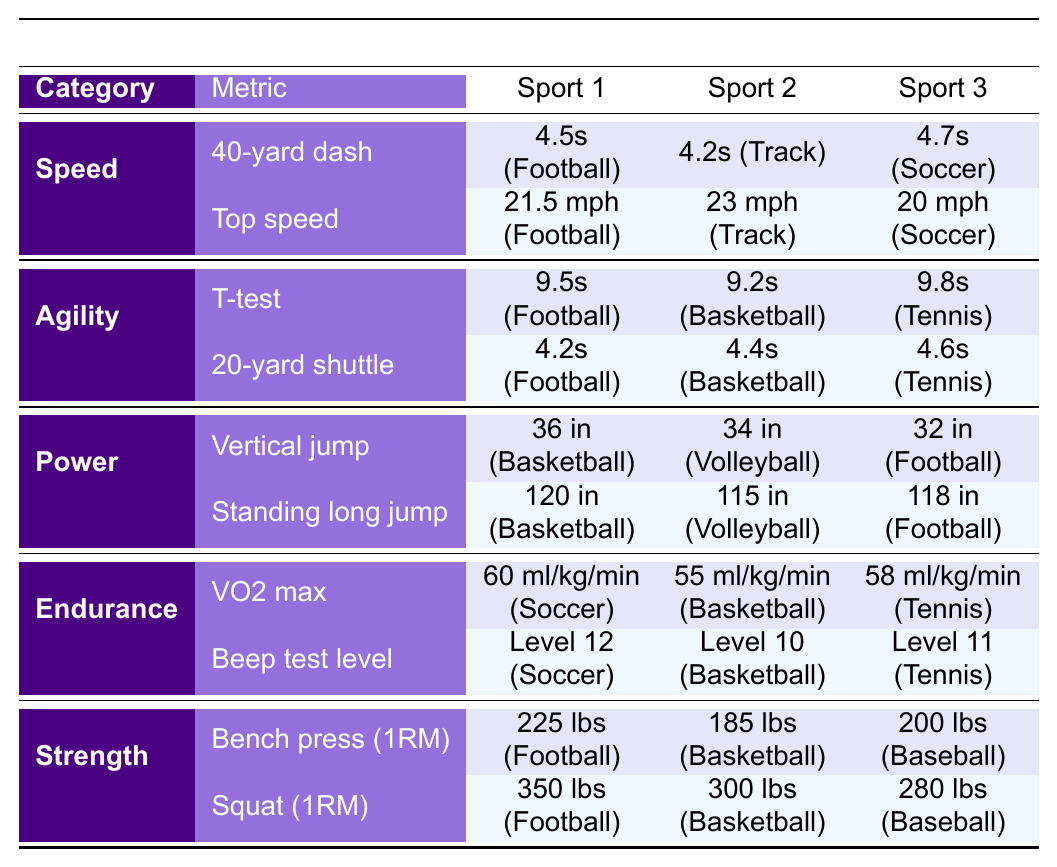What's the fastest time for the 40-yard dash among the sports listed? The fastest time for the 40-yard dash is listed under Track with a time of 4.2 seconds.
Answer: 4.2 seconds Which sport has the highest value for vertical jump? The vertical jump value is highest for Basketball at 36 inches, compared to Volleyball at 34 inches and Football at 32 inches.
Answer: Basketball with 36 inches What is the VO2 max for Soccer? The VO2 max for Soccer is specifically listed as 60 ml/kg/min in the endurance section of the table.
Answer: 60 ml/kg/min Is the standing long jump for Football greater than 120 inches? The value for the standing long jump in Football is 118 inches, which is less than 120 inches.
Answer: No What is the difference in bench press strength between Football and Basketball? The bench press for Football is 225 lbs and for Basketball is 185 lbs. The difference is 225 lbs - 185 lbs = 40 lbs.
Answer: 40 lbs In which sport is the top speed the highest, and what is that speed? The top speed is highest in Track at 23 mph compared to Soccer at 20 mph and Football at 21.5 mph.
Answer: Track at 23 mph Which sport has the lowest score in the 20-yard shuttle? In the 20-yard shuttle, Football has the lowest score at 4.2 seconds, compared to Basketball at 4.4 seconds and Tennis at 4.6 seconds.
Answer: Football What is the average squat weight among the sports listed? The squat weights are 350 lbs (Football), 300 lbs (Basketball), and 280 lbs (Baseball). The average is (350 + 300 + 280) / 3 = 310 lbs.
Answer: 310 lbs Is the T-test score for Tennis higher than that for Basketball? The T-test score for Tennis is 9.8 seconds, which is higher than Basketball's score of 9.2 seconds.
Answer: Yes Compare the endurance levels (VO2 max) between Tennis and Basketball. Which is higher? The VO2 max for Tennis is 58 ml/kg/min, while for Basketball it is 55 ml/kg/min, thus Tennis has the higher score.
Answer: Tennis is higher 